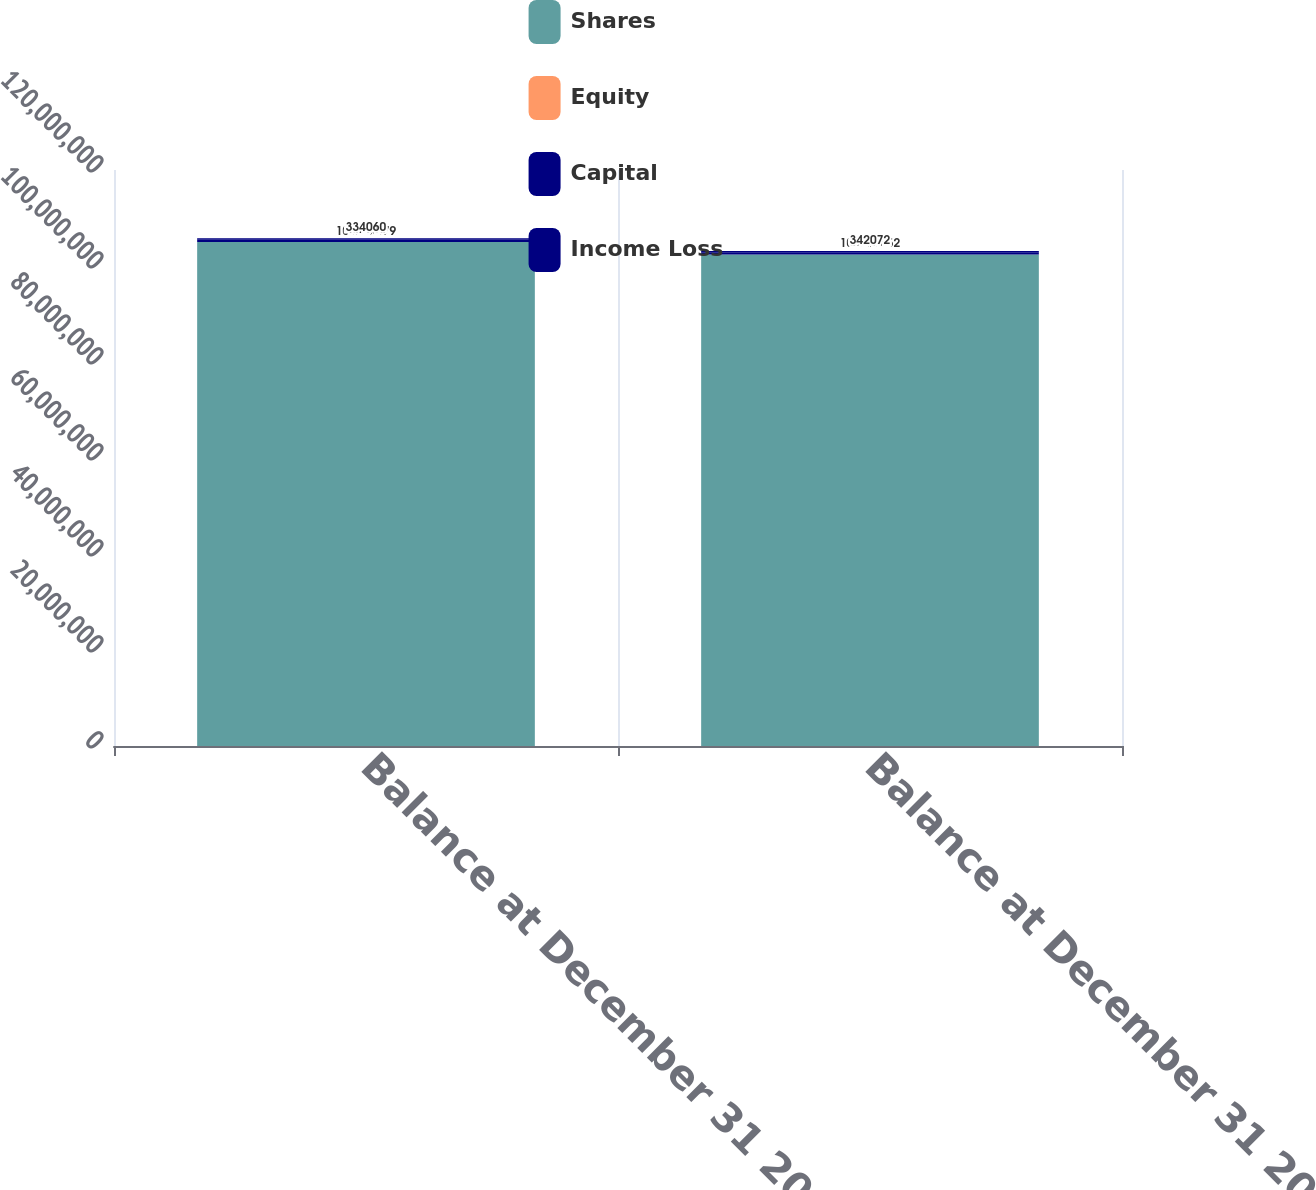<chart> <loc_0><loc_0><loc_500><loc_500><stacked_bar_chart><ecel><fcel>Balance at December 31 2007<fcel>Balance at December 31 2008<nl><fcel>Shares<fcel>1.05019e+08<fcel>1.02398e+08<nl><fcel>Equity<fcel>1050<fcel>1024<nl><fcel>Capital<fcel>432916<fcel>379104<nl><fcel>Income Loss<fcel>334060<fcel>342072<nl></chart> 